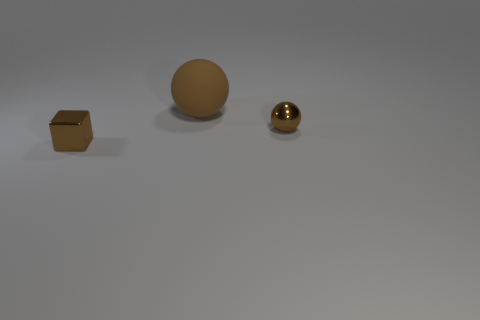What is the size of the metallic object that is the same color as the cube?
Ensure brevity in your answer.  Small. Are there any big spheres made of the same material as the cube?
Provide a succinct answer. No. Is the number of green cylinders greater than the number of small brown shiny balls?
Your answer should be very brief. No. Is the small brown cube made of the same material as the large brown sphere?
Give a very brief answer. No. What number of rubber things are either large yellow cubes or tiny brown cubes?
Your answer should be very brief. 0. What is the color of the cube that is the same size as the metallic sphere?
Your answer should be compact. Brown. What number of brown metallic objects are the same shape as the big brown matte object?
Ensure brevity in your answer.  1. What number of cylinders are big blue matte objects or metal objects?
Ensure brevity in your answer.  0. There is a small brown object that is behind the tiny shiny block; does it have the same shape as the brown rubber thing to the right of the tiny brown block?
Keep it short and to the point. Yes. What is the small ball made of?
Offer a terse response. Metal. 